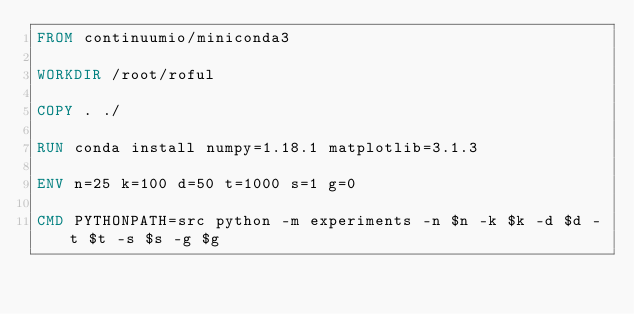Convert code to text. <code><loc_0><loc_0><loc_500><loc_500><_Dockerfile_>FROM continuumio/miniconda3

WORKDIR /root/roful

COPY . ./

RUN conda install numpy=1.18.1 matplotlib=3.1.3

ENV n=25 k=100 d=50 t=1000 s=1 g=0

CMD PYTHONPATH=src python -m experiments -n $n -k $k -d $d -t $t -s $s -g $g</code> 